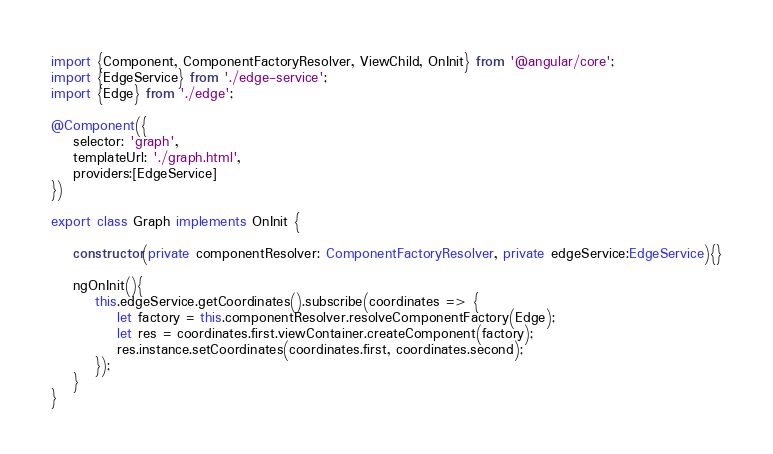Convert code to text. <code><loc_0><loc_0><loc_500><loc_500><_TypeScript_>import {Component, ComponentFactoryResolver, ViewChild, OnInit} from '@angular/core';
import {EdgeService} from './edge-service';
import {Edge} from './edge';

@Component({
    selector: 'graph',
    templateUrl: './graph.html',
    providers:[EdgeService]
})

export class Graph implements OnInit {

    constructor(private componentResolver: ComponentFactoryResolver, private edgeService:EdgeService){}

    ngOnInit(){
        this.edgeService.getCoordinates().subscribe(coordinates => {
            let factory = this.componentResolver.resolveComponentFactory(Edge);
            let res = coordinates.first.viewContainer.createComponent(factory);
            res.instance.setCoordinates(coordinates.first, coordinates.second);
        });
    }
}</code> 